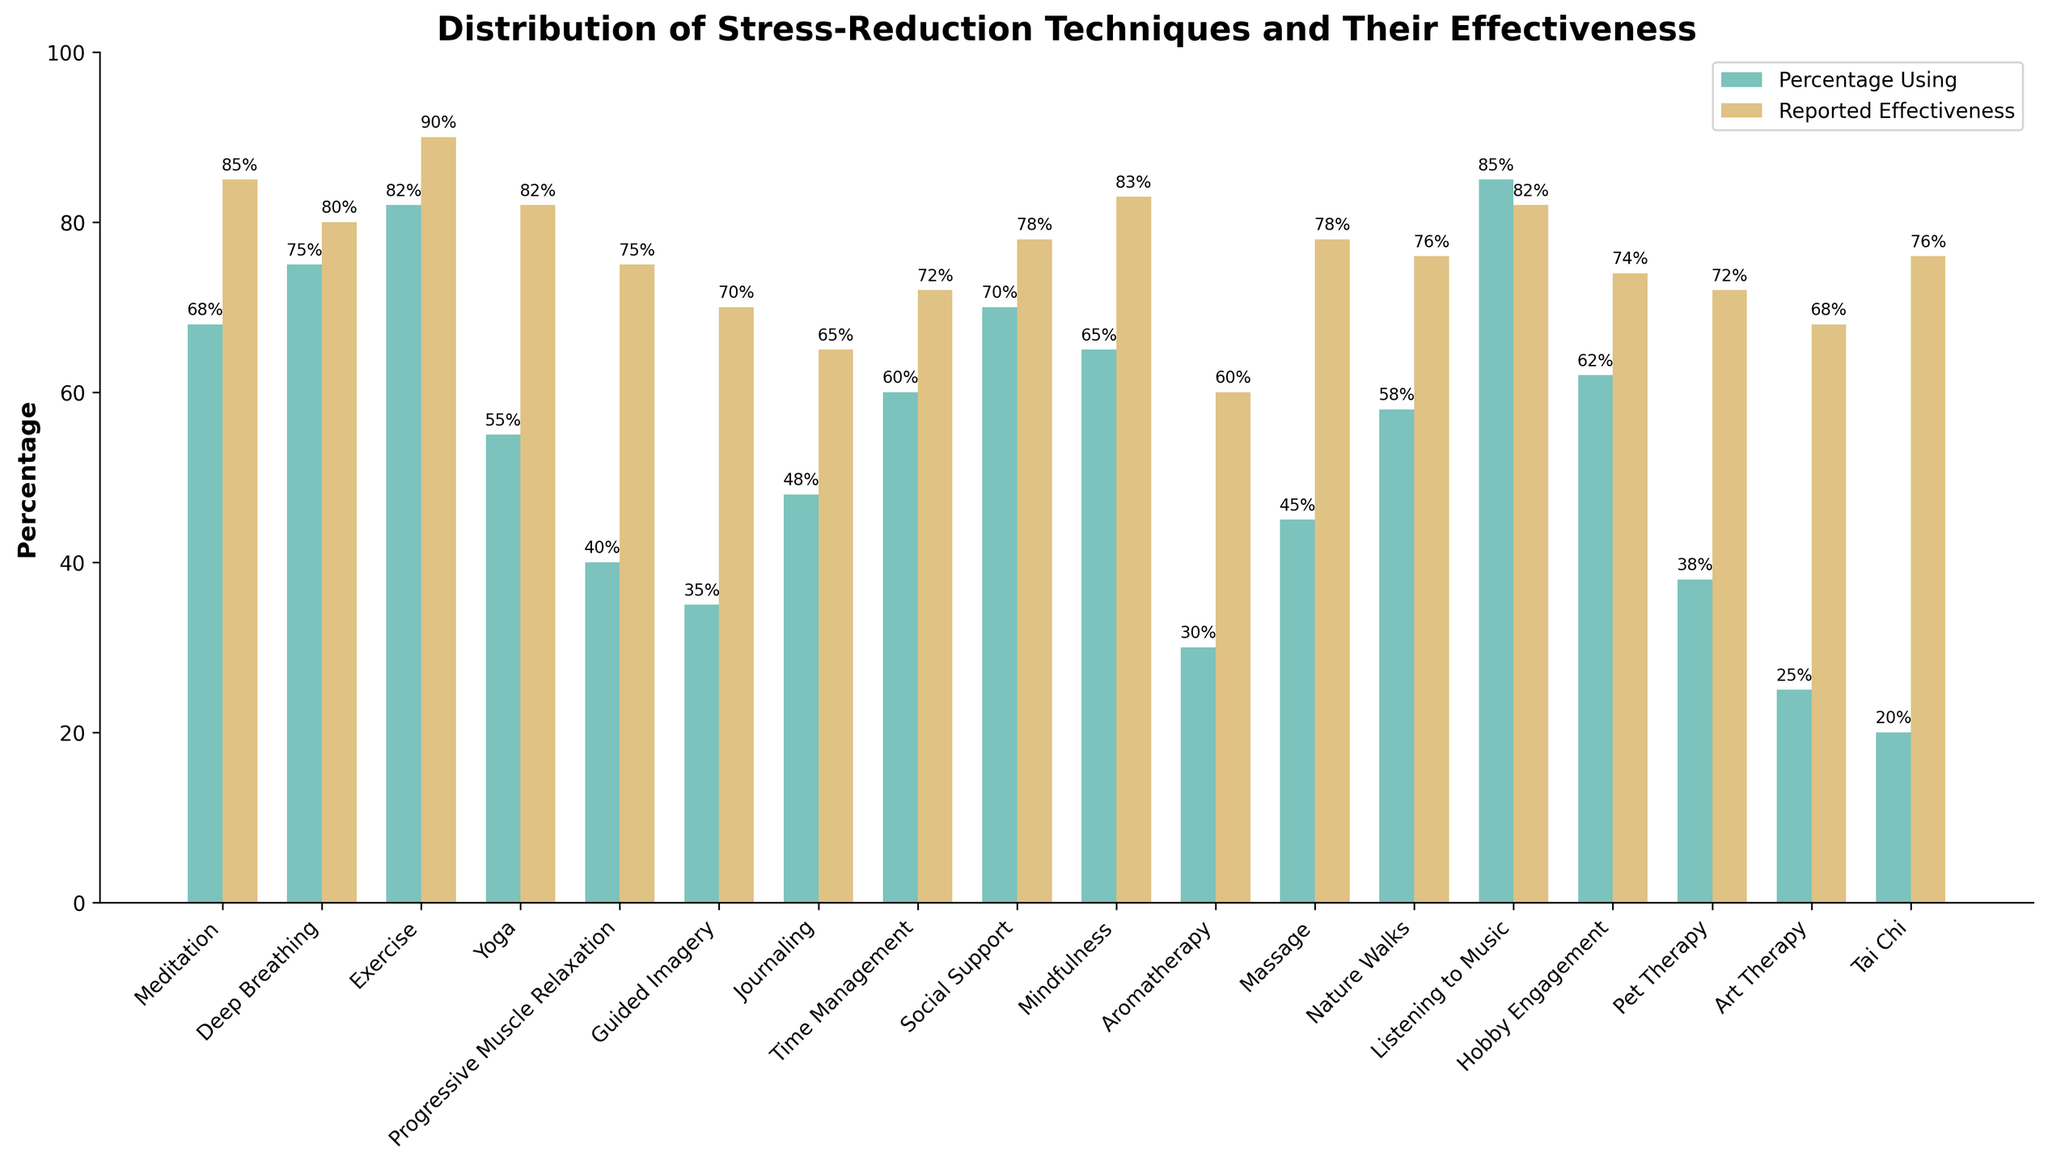Which stress-reduction technique is used by the highest percentage of people? By looking at the bars representing the 'Percentage Using', the tallest bar represents Listening to Music at 85%, which is the highest percentage depicted.
Answer: Listening to Music Which two techniques have the closest reported effectiveness percentages? The two techniques with the closest bars under 'Reported Effectiveness' are Deep Breathing and Massage, both having effectiveness percentages of 80% and 78% respectively.
Answer: Deep Breathing and Massage What's the difference between the reported effectiveness of Meditation and Tai Chi? The height of the bar for Meditation under 'Reported Effectiveness' is 85%, and for Tai Chi, it is 76%. The difference can be calculated as 85 - 76 = 9.
Answer: 9% Which technique has a higher reported effectiveness: Journaling or Nature Walks? By comparing the heights of the bars representing 'Reported Effectiveness' for Journaling and Nature Walks, Nature Walks is higher at 76%, compared to Journaling at 65%.
Answer: Nature Walks What's the sum of the percentages using Yoga and Time Management? The percentage using Yoga is represented by the bar at 55%, and Time Management by the bar at 60%. Summing these, we get 55 + 60 = 115.
Answer: 115% Which technique has a marked discrepancy between its usage and reported effectiveness, being high in one and low in the other category? The technique with a high bar in 'Percentage Using' but a relatively lower bar in 'Reported Effectiveness' is Listening to Music, with usage at 85% and effectiveness at 82%. While it's not drastically discrepant, it emphasizes the idea.
Answer: Listening to Music Which technique ranks higher in reported effectiveness, Meditation or Mindfulness, and by how much? Comparing their bars under 'Reported Effectiveness', Meditation is at 85% and Mindfulness is at 83%. The difference is 85 - 83 = 2.
Answer: Meditation by 2% What’s the average reported effectiveness across all techniques? Adding the percentage values of reported effectiveness across all techniques (85 + 80 + 90 + 82 + 75 + 70 + 65 + 72 + 78 + 83 + 60 + 78 + 76 + 82 + 74 + 72 + 68 + 76) and dividing by the number of techniques (18 total), the average is (1266 / 18) = 70.33.
Answer: 70.33% Which has greater disparity between usage and effectiveness, Guided Imagery or Pet Therapy? By examining the differences visually from the bars, Guided Imagery has a usage of 35% and effectiveness of 70%, a disparity of 35%. Pet Therapy has a usage of 38% and effectiveness of 72%, a disparity of 34%. Guided Imagery has a greater disparity.
Answer: Guided Imagery 